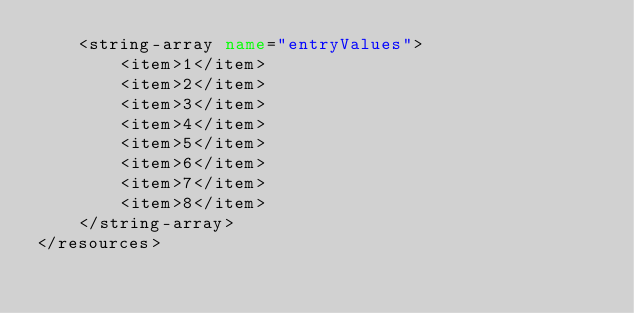Convert code to text. <code><loc_0><loc_0><loc_500><loc_500><_XML_>    <string-array name="entryValues">
        <item>1</item>
        <item>2</item>
        <item>3</item>
        <item>4</item>
        <item>5</item>
        <item>6</item>
        <item>7</item>
        <item>8</item>
    </string-array>
</resources>
</code> 